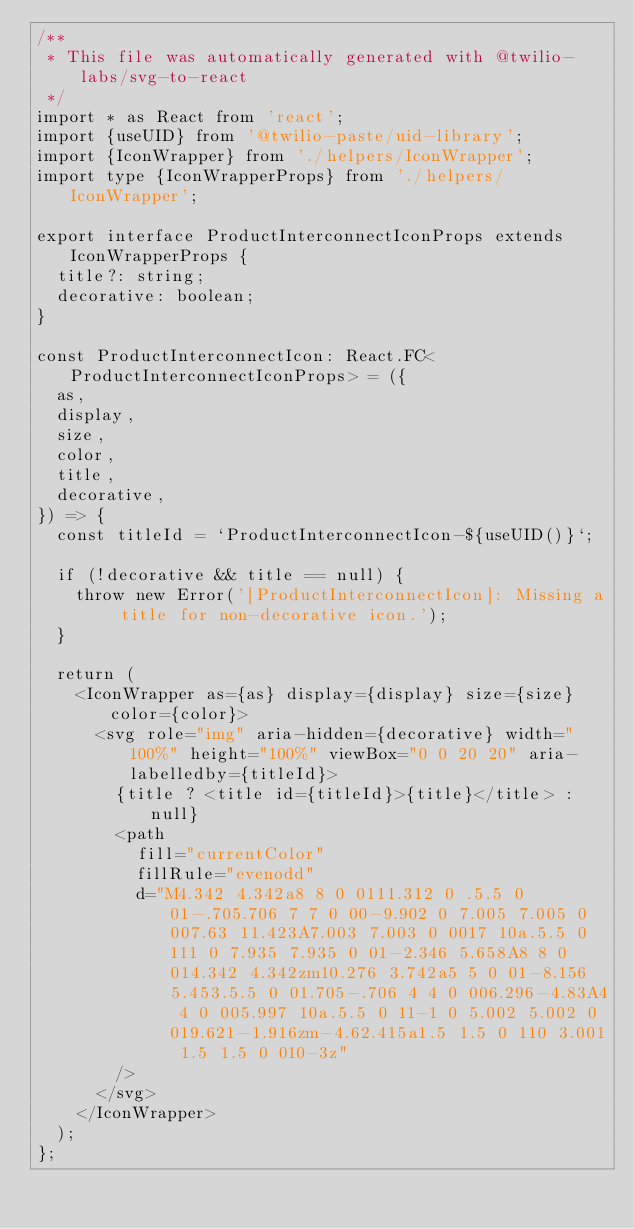<code> <loc_0><loc_0><loc_500><loc_500><_TypeScript_>/**
 * This file was automatically generated with @twilio-labs/svg-to-react
 */
import * as React from 'react';
import {useUID} from '@twilio-paste/uid-library';
import {IconWrapper} from './helpers/IconWrapper';
import type {IconWrapperProps} from './helpers/IconWrapper';

export interface ProductInterconnectIconProps extends IconWrapperProps {
  title?: string;
  decorative: boolean;
}

const ProductInterconnectIcon: React.FC<ProductInterconnectIconProps> = ({
  as,
  display,
  size,
  color,
  title,
  decorative,
}) => {
  const titleId = `ProductInterconnectIcon-${useUID()}`;

  if (!decorative && title == null) {
    throw new Error('[ProductInterconnectIcon]: Missing a title for non-decorative icon.');
  }

  return (
    <IconWrapper as={as} display={display} size={size} color={color}>
      <svg role="img" aria-hidden={decorative} width="100%" height="100%" viewBox="0 0 20 20" aria-labelledby={titleId}>
        {title ? <title id={titleId}>{title}</title> : null}
        <path
          fill="currentColor"
          fillRule="evenodd"
          d="M4.342 4.342a8 8 0 0111.312 0 .5.5 0 01-.705.706 7 7 0 00-9.902 0 7.005 7.005 0 007.63 11.423A7.003 7.003 0 0017 10a.5.5 0 111 0 7.935 7.935 0 01-2.346 5.658A8 8 0 014.342 4.342zm10.276 3.742a5 5 0 01-8.156 5.453.5.5 0 01.705-.706 4 4 0 006.296-4.83A4 4 0 005.997 10a.5.5 0 11-1 0 5.002 5.002 0 019.621-1.916zm-4.62.415a1.5 1.5 0 110 3.001 1.5 1.5 0 010-3z"
        />
      </svg>
    </IconWrapper>
  );
};
</code> 